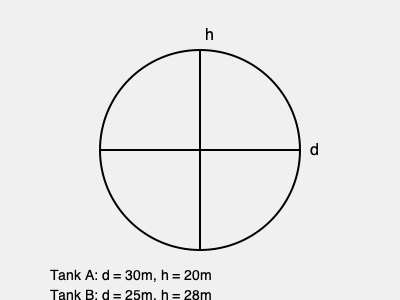As part of a new oil storage facility project, you need to determine which of two proposed cylindrical tanks has the largest volume. Tank A has a diameter of 30 meters and a height of 20 meters, while Tank B has a diameter of 25 meters and a height of 28 meters. Which tank has the larger volume and by how many cubic meters? To solve this problem, we need to calculate the volume of each cylindrical tank and compare them. The formula for the volume of a cylinder is:

$$ V = \pi r^2 h $$

Where $V$ is volume, $r$ is radius (half the diameter), and $h$ is height.

1. Calculate the volume of Tank A:
   - Diameter = 30m, so radius = 15m
   - Height = 20m
   $$ V_A = \pi (15\text{m})^2 (20\text{m}) = 14,137.17 \text{m}^3 $$

2. Calculate the volume of Tank B:
   - Diameter = 25m, so radius = 12.5m
   - Height = 28m
   $$ V_B = \pi (12.5\text{m})^2 (28\text{m}) = 13,744.47 \text{m}^3 $$

3. Compare the volumes:
   $$ V_A - V_B = 14,137.17 \text{m}^3 - 13,744.47 \text{m}^3 = 392.7 \text{m}^3 $$

Tank A has the larger volume, exceeding Tank B's volume by approximately 392.7 cubic meters.
Answer: Tank A; 392.7 m³ 